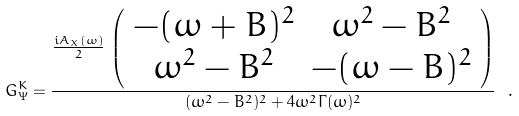<formula> <loc_0><loc_0><loc_500><loc_500>G _ { \Psi } ^ { K } = \frac { \frac { i A _ { X } ( \omega ) } { 2 } \, \left ( \begin{array} { c c } - ( \omega + B ) ^ { 2 } & \omega ^ { 2 } - B ^ { 2 } \\ \omega ^ { 2 } - B ^ { 2 } & - ( \omega - B ) ^ { 2 } \end{array} \right ) } { ( \omega ^ { 2 } - B ^ { 2 } ) ^ { 2 } + 4 \omega ^ { 2 } \Gamma ( \omega ) ^ { 2 } } \ .</formula> 